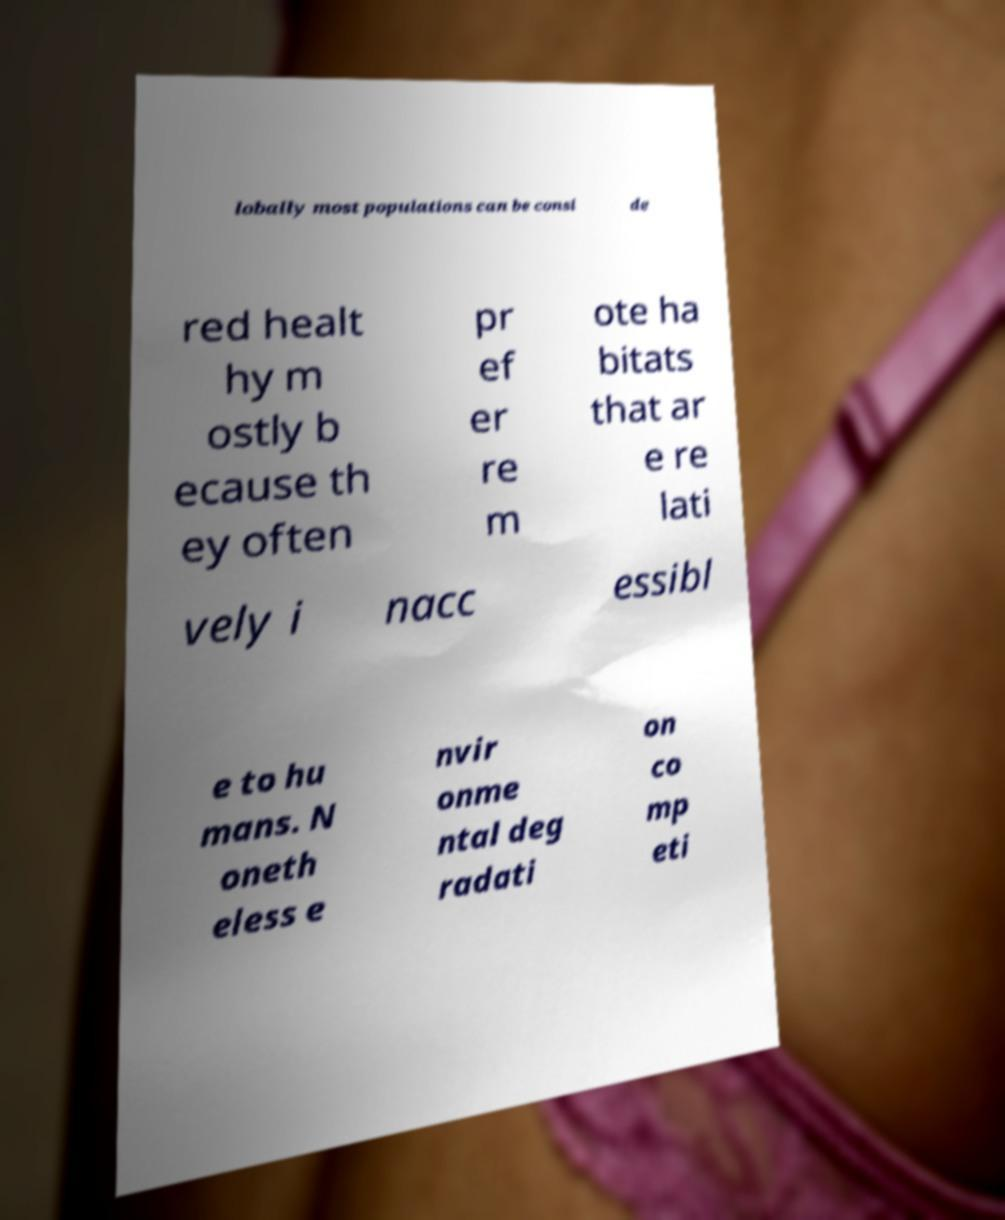What messages or text are displayed in this image? I need them in a readable, typed format. lobally most populations can be consi de red healt hy m ostly b ecause th ey often pr ef er re m ote ha bitats that ar e re lati vely i nacc essibl e to hu mans. N oneth eless e nvir onme ntal deg radati on co mp eti 